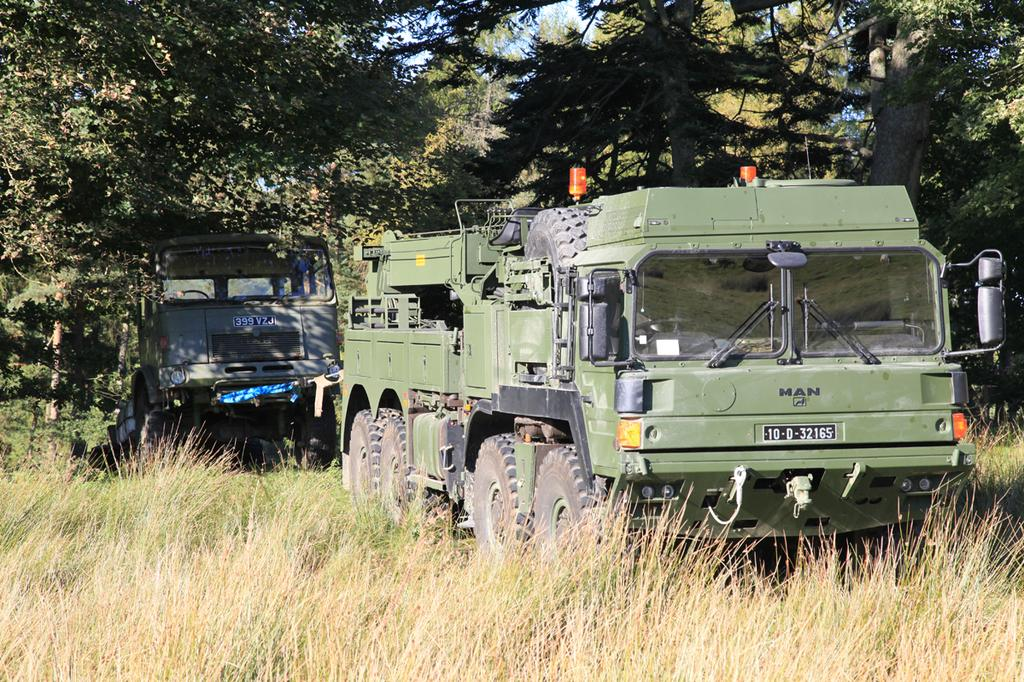What can be seen in the center of the image? There are two vehicles with number plates in the center of the image. What is visible in the background of the image? The sky, trees, and grass are visible in the background of the image. Can you tell me how many crooks are hiding behind the trees in the image? There are no crooks present in the image; it only features two vehicles with number plates, the sky, trees, and grass in the background. 